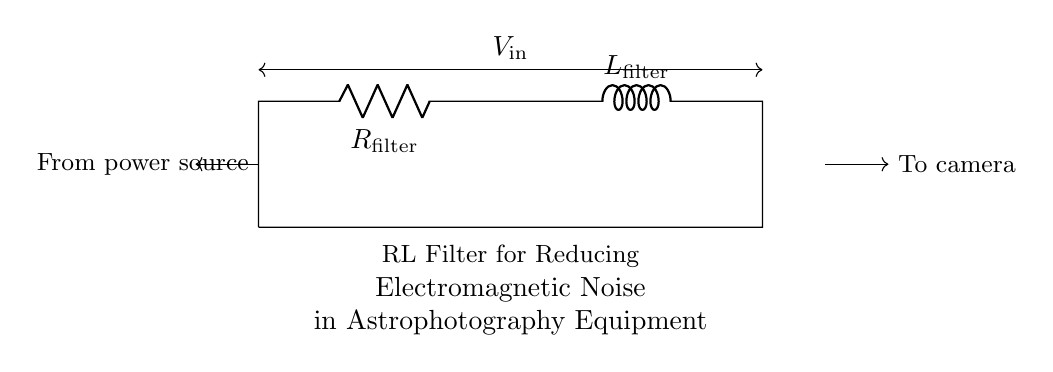What components are shown in the circuit? The components are a resistor and an inductor, as indicated by the symbols marked R and L. The resistor is labeled as R_filter and the inductor as L_filter.
Answer: Resistor and inductor What is the function of the resistor in this circuit? The resistor is used to limit the current flowing through the circuit, which helps in reducing electromagnetic noise by dissipating excess power as heat.
Answer: Current limiting What type of filter is represented by this circuit? The circuit represents an RL low-pass filter, designed to allow low-frequency signals to pass while attenuating high-frequency noise.
Answer: RL low-pass filter What is the purpose of this circuit in the context provided? The circuit is meant for reducing electromagnetic noise specifically in astrophotography equipment, which can be affected by interference.
Answer: Noise reduction in astrophotography How does the inductor contribute to the circuit's function? The inductor stores energy in a magnetic field when current passes through it, thereby opposing changes in current and further smoothing out any fluctuations that contribute to noise.
Answer: Energy storage and smoothing What is the relationship between the input and output voltages in this RL filter? The output voltage across the inductor will be lower than the input voltage due to the voltage drop across the resistor and the filtering action of the inductor.
Answer: Output voltage lower than input 